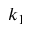<formula> <loc_0><loc_0><loc_500><loc_500>k _ { 1 }</formula> 